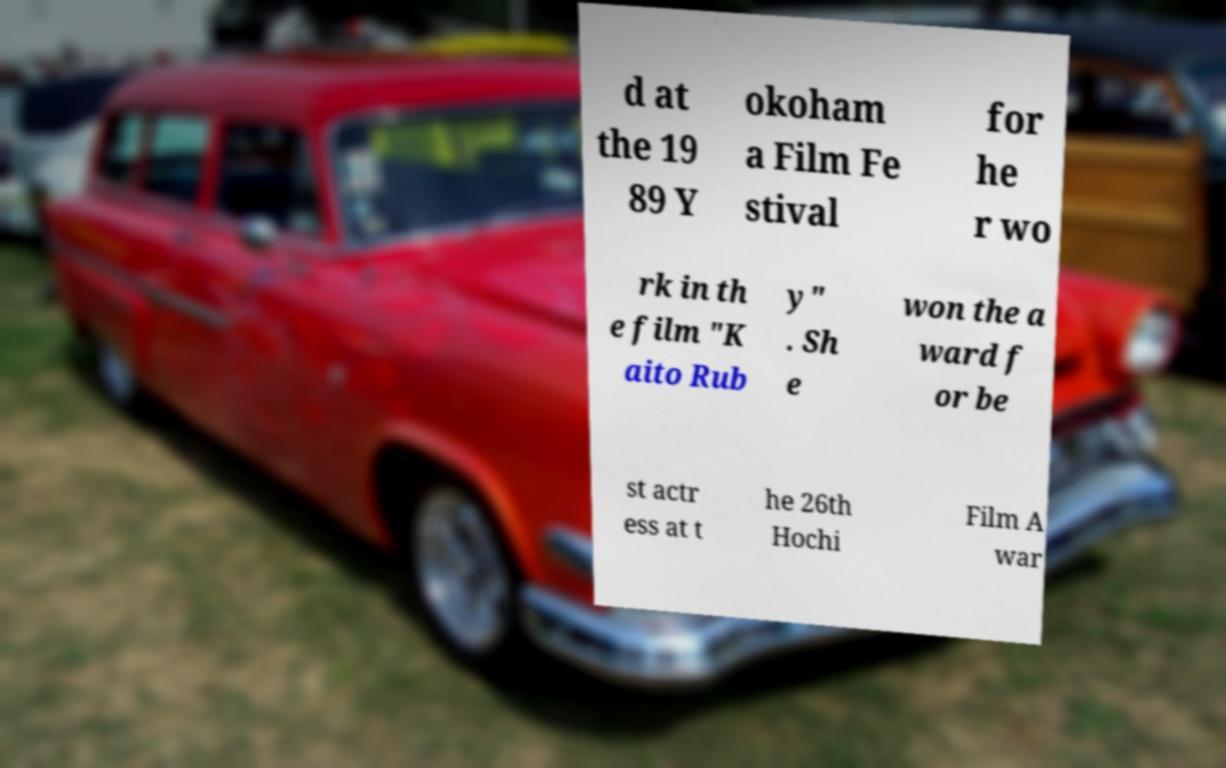Could you extract and type out the text from this image? d at the 19 89 Y okoham a Film Fe stival for he r wo rk in th e film "K aito Rub y" . Sh e won the a ward f or be st actr ess at t he 26th Hochi Film A war 